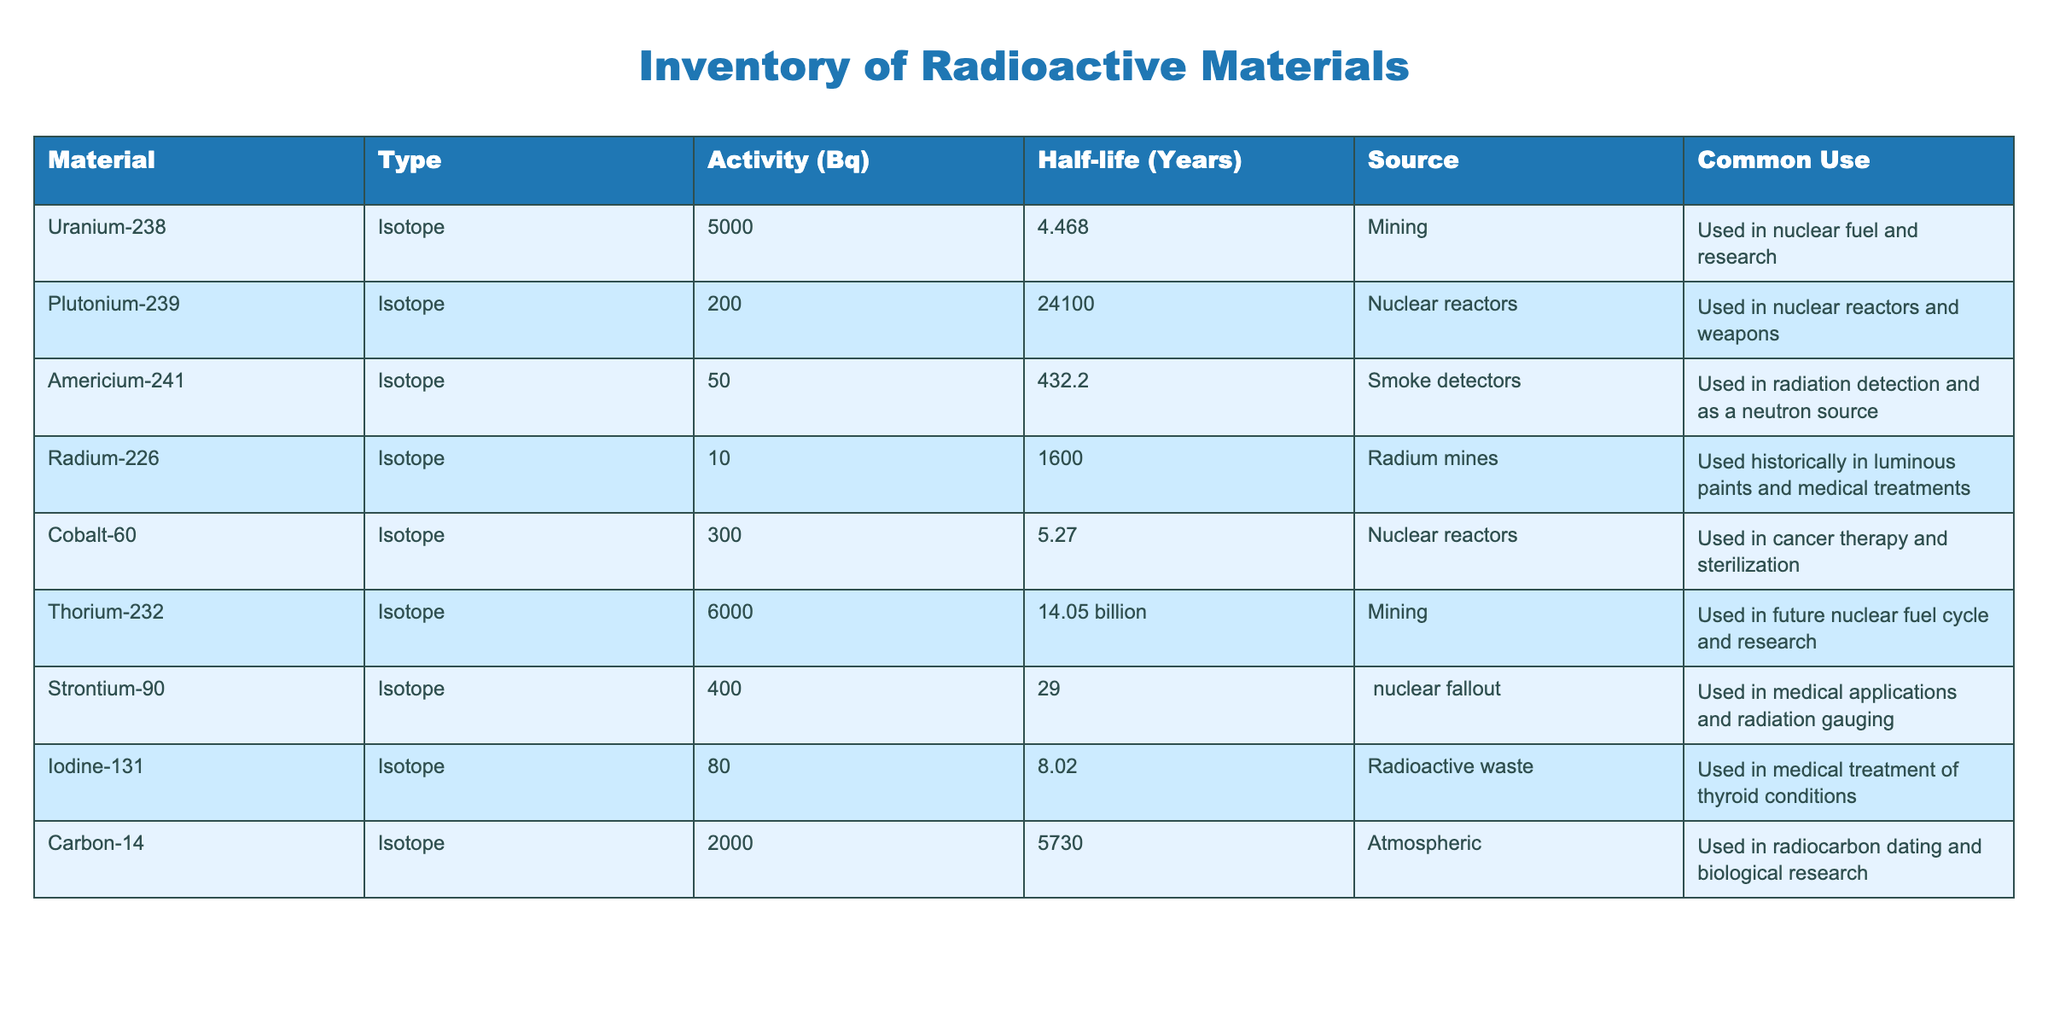What is the activity of Uranium-238? The table lists Uranium-238 with an activity value of 5000 Bq.
Answer: 5000 Bq Which material has the longest half-life? The half-lives of each material are listed in the table. Thorium-232 has a half-life of 14.05 billion years, which is longer than any other material's half-life.
Answer: Thorium-232 Is Strontium-90 used in medical applications? According to the table, Strontium-90 is listed under "Common Use" as being utilized in medical applications.
Answer: Yes What is the total activity of the isotopes used in nuclear reactors? The table shows that Cobalt-60 has an activity of 300 Bq and Plutonium-239 has an activity of 200 Bq. Summing these gives 300 + 200 = 500 Bq, which is the total activity for isotopes used in nuclear reactors.
Answer: 500 Bq Is there any radioactive material listed that is used in smoke detectors? The table indicates that Americium-241 is specifically mentioned as being used in smoke detectors.
Answer: Yes What is the average half-life of the isotopes used in small-scale nuclear experiments? The half-lives are 4.468, 24100, 432.2, 1600, 5.27, 14.05 billion, 29, 8.02, and 5730 years for a total of 14 values. Converting 14.05 billion years to a standard format (14,050,000,000 years) and summing them gives 14,064,171,064. Then, dividing by 9 gives an average half-life of 1,562,241,196 years.
Answer: 1,562,241,196 years What materials are primarily sourced from mining according to the table? The table lists Uranium-238 and Thorium-232 with the source indicated as "Mining". Hence, both materials are sourced from mining.
Answer: Uranium-238, Thorium-232 Does the table list any isotopes that are used in radiation detection? The table states that Americium-241 is used for radiation detection, confirming that there is at least one isotope serving this application.
Answer: Yes Which isotope has the highest activity among those listed? Reviewing the table, the highest activity is associated with Uranium-238 with a value of 5000 Bq.
Answer: Uranium-238 